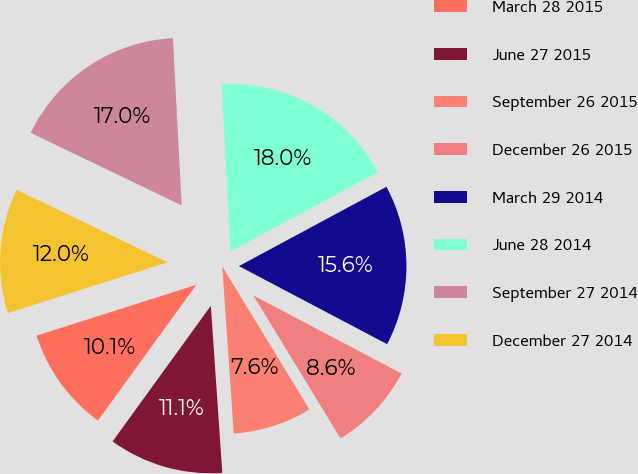Convert chart. <chart><loc_0><loc_0><loc_500><loc_500><pie_chart><fcel>March 28 2015<fcel>June 27 2015<fcel>September 26 2015<fcel>December 26 2015<fcel>March 29 2014<fcel>June 28 2014<fcel>September 27 2014<fcel>December 27 2014<nl><fcel>10.13%<fcel>11.07%<fcel>7.62%<fcel>8.57%<fcel>15.57%<fcel>17.98%<fcel>17.04%<fcel>12.02%<nl></chart> 